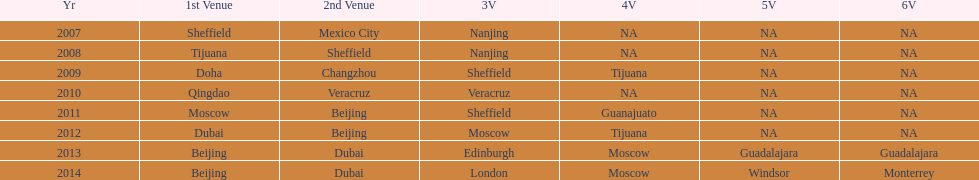Which is the only year that mexico is on a venue 2007. Could you parse the entire table? {'header': ['Yr', '1st Venue', '2nd Venue', '3V', '4V', '5V', '6V'], 'rows': [['2007', 'Sheffield', 'Mexico City', 'Nanjing', 'NA', 'NA', 'NA'], ['2008', 'Tijuana', 'Sheffield', 'Nanjing', 'NA', 'NA', 'NA'], ['2009', 'Doha', 'Changzhou', 'Sheffield', 'Tijuana', 'NA', 'NA'], ['2010', 'Qingdao', 'Veracruz', 'Veracruz', 'NA', 'NA', 'NA'], ['2011', 'Moscow', 'Beijing', 'Sheffield', 'Guanajuato', 'NA', 'NA'], ['2012', 'Dubai', 'Beijing', 'Moscow', 'Tijuana', 'NA', 'NA'], ['2013', 'Beijing', 'Dubai', 'Edinburgh', 'Moscow', 'Guadalajara', 'Guadalajara'], ['2014', 'Beijing', 'Dubai', 'London', 'Moscow', 'Windsor', 'Monterrey']]} 